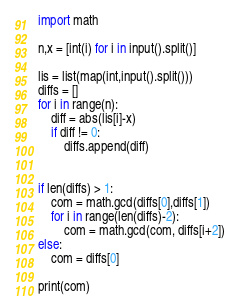Convert code to text. <code><loc_0><loc_0><loc_500><loc_500><_Python_>import math

n,x = [int(i) for i in input().split()]

lis = list(map(int,input().split()))
diffs = []
for i in range(n):
    diff = abs(lis[i]-x)
    if diff != 0:
        diffs.append(diff)


if len(diffs) > 1:
    com = math.gcd(diffs[0],diffs[1])
    for i in range(len(diffs)-2):
        com = math.gcd(com, diffs[i+2])
else:
    com = diffs[0]

print(com)</code> 